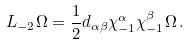<formula> <loc_0><loc_0><loc_500><loc_500>L _ { - 2 } \Omega = \frac { 1 } { 2 } d _ { \alpha \beta } \chi ^ { \alpha } _ { - 1 } \chi ^ { \beta } _ { - 1 } \Omega \, .</formula> 